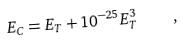Convert formula to latex. <formula><loc_0><loc_0><loc_500><loc_500>E _ { C } = E _ { T } + 1 0 ^ { - 2 5 } E _ { T } ^ { 3 } \quad ,</formula> 